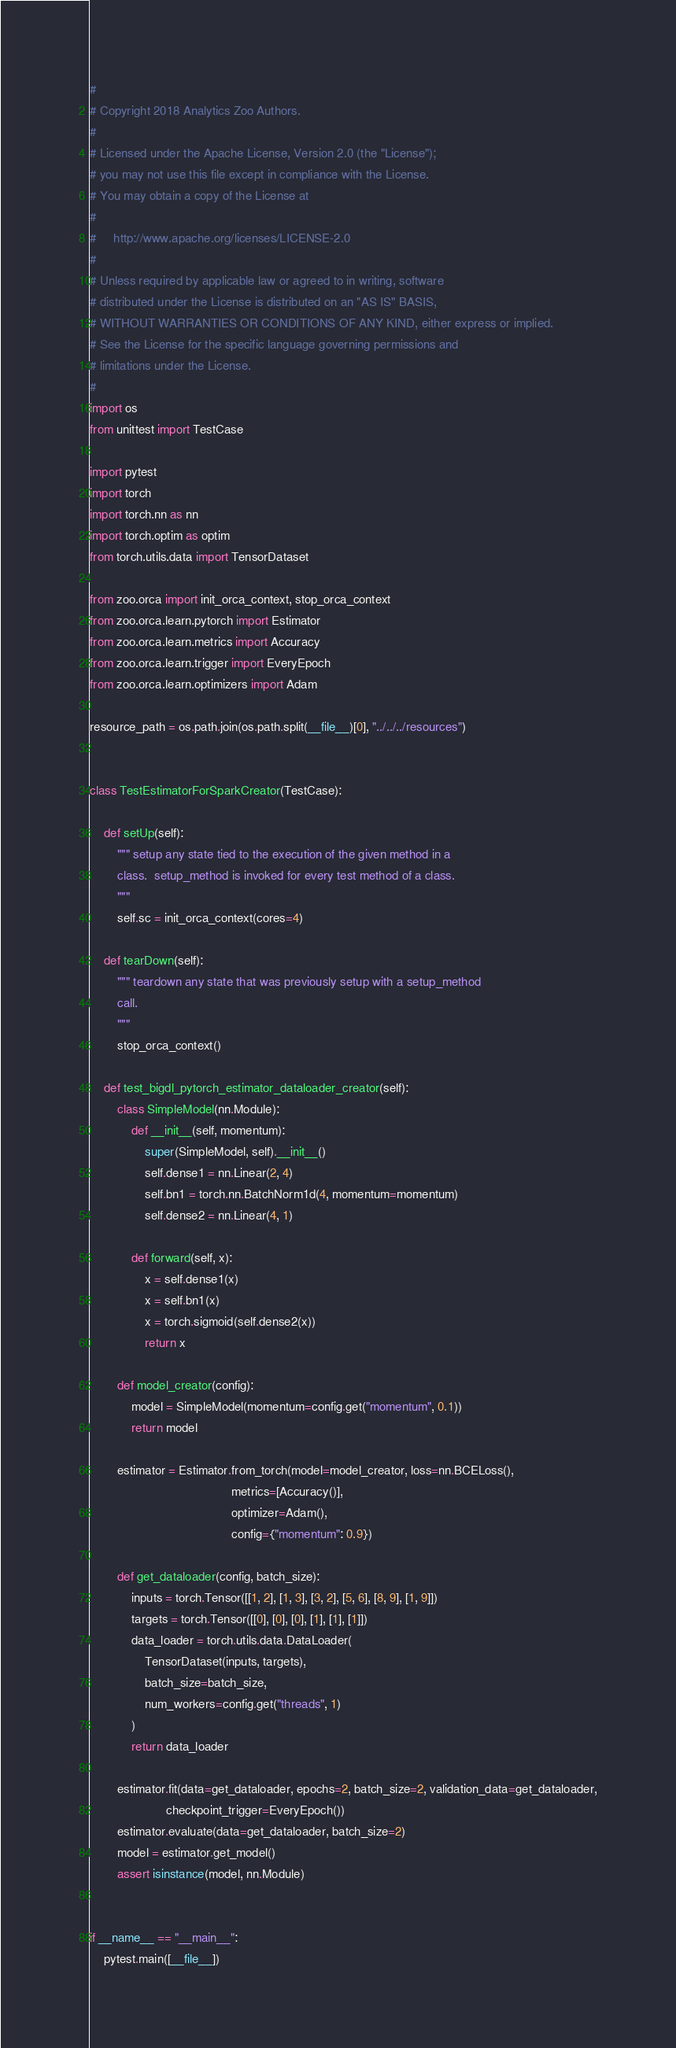<code> <loc_0><loc_0><loc_500><loc_500><_Python_>#
# Copyright 2018 Analytics Zoo Authors.
#
# Licensed under the Apache License, Version 2.0 (the "License");
# you may not use this file except in compliance with the License.
# You may obtain a copy of the License at
#
#     http://www.apache.org/licenses/LICENSE-2.0
#
# Unless required by applicable law or agreed to in writing, software
# distributed under the License is distributed on an "AS IS" BASIS,
# WITHOUT WARRANTIES OR CONDITIONS OF ANY KIND, either express or implied.
# See the License for the specific language governing permissions and
# limitations under the License.
#
import os
from unittest import TestCase

import pytest
import torch
import torch.nn as nn
import torch.optim as optim
from torch.utils.data import TensorDataset

from zoo.orca import init_orca_context, stop_orca_context
from zoo.orca.learn.pytorch import Estimator
from zoo.orca.learn.metrics import Accuracy
from zoo.orca.learn.trigger import EveryEpoch
from zoo.orca.learn.optimizers import Adam

resource_path = os.path.join(os.path.split(__file__)[0], "../../../resources")


class TestEstimatorForSparkCreator(TestCase):

    def setUp(self):
        """ setup any state tied to the execution of the given method in a
        class.  setup_method is invoked for every test method of a class.
        """
        self.sc = init_orca_context(cores=4)

    def tearDown(self):
        """ teardown any state that was previously setup with a setup_method
        call.
        """
        stop_orca_context()

    def test_bigdl_pytorch_estimator_dataloader_creator(self):
        class SimpleModel(nn.Module):
            def __init__(self, momentum):
                super(SimpleModel, self).__init__()
                self.dense1 = nn.Linear(2, 4)
                self.bn1 = torch.nn.BatchNorm1d(4, momentum=momentum)
                self.dense2 = nn.Linear(4, 1)

            def forward(self, x):
                x = self.dense1(x)
                x = self.bn1(x)
                x = torch.sigmoid(self.dense2(x))
                return x

        def model_creator(config):
            model = SimpleModel(momentum=config.get("momentum", 0.1))
            return model

        estimator = Estimator.from_torch(model=model_creator, loss=nn.BCELoss(),
                                         metrics=[Accuracy()],
                                         optimizer=Adam(),
                                         config={"momentum": 0.9})

        def get_dataloader(config, batch_size):
            inputs = torch.Tensor([[1, 2], [1, 3], [3, 2], [5, 6], [8, 9], [1, 9]])
            targets = torch.Tensor([[0], [0], [0], [1], [1], [1]])
            data_loader = torch.utils.data.DataLoader(
                TensorDataset(inputs, targets),
                batch_size=batch_size,
                num_workers=config.get("threads", 1)
            )
            return data_loader

        estimator.fit(data=get_dataloader, epochs=2, batch_size=2, validation_data=get_dataloader,
                      checkpoint_trigger=EveryEpoch())
        estimator.evaluate(data=get_dataloader, batch_size=2)
        model = estimator.get_model()
        assert isinstance(model, nn.Module)


if __name__ == "__main__":
    pytest.main([__file__])
</code> 